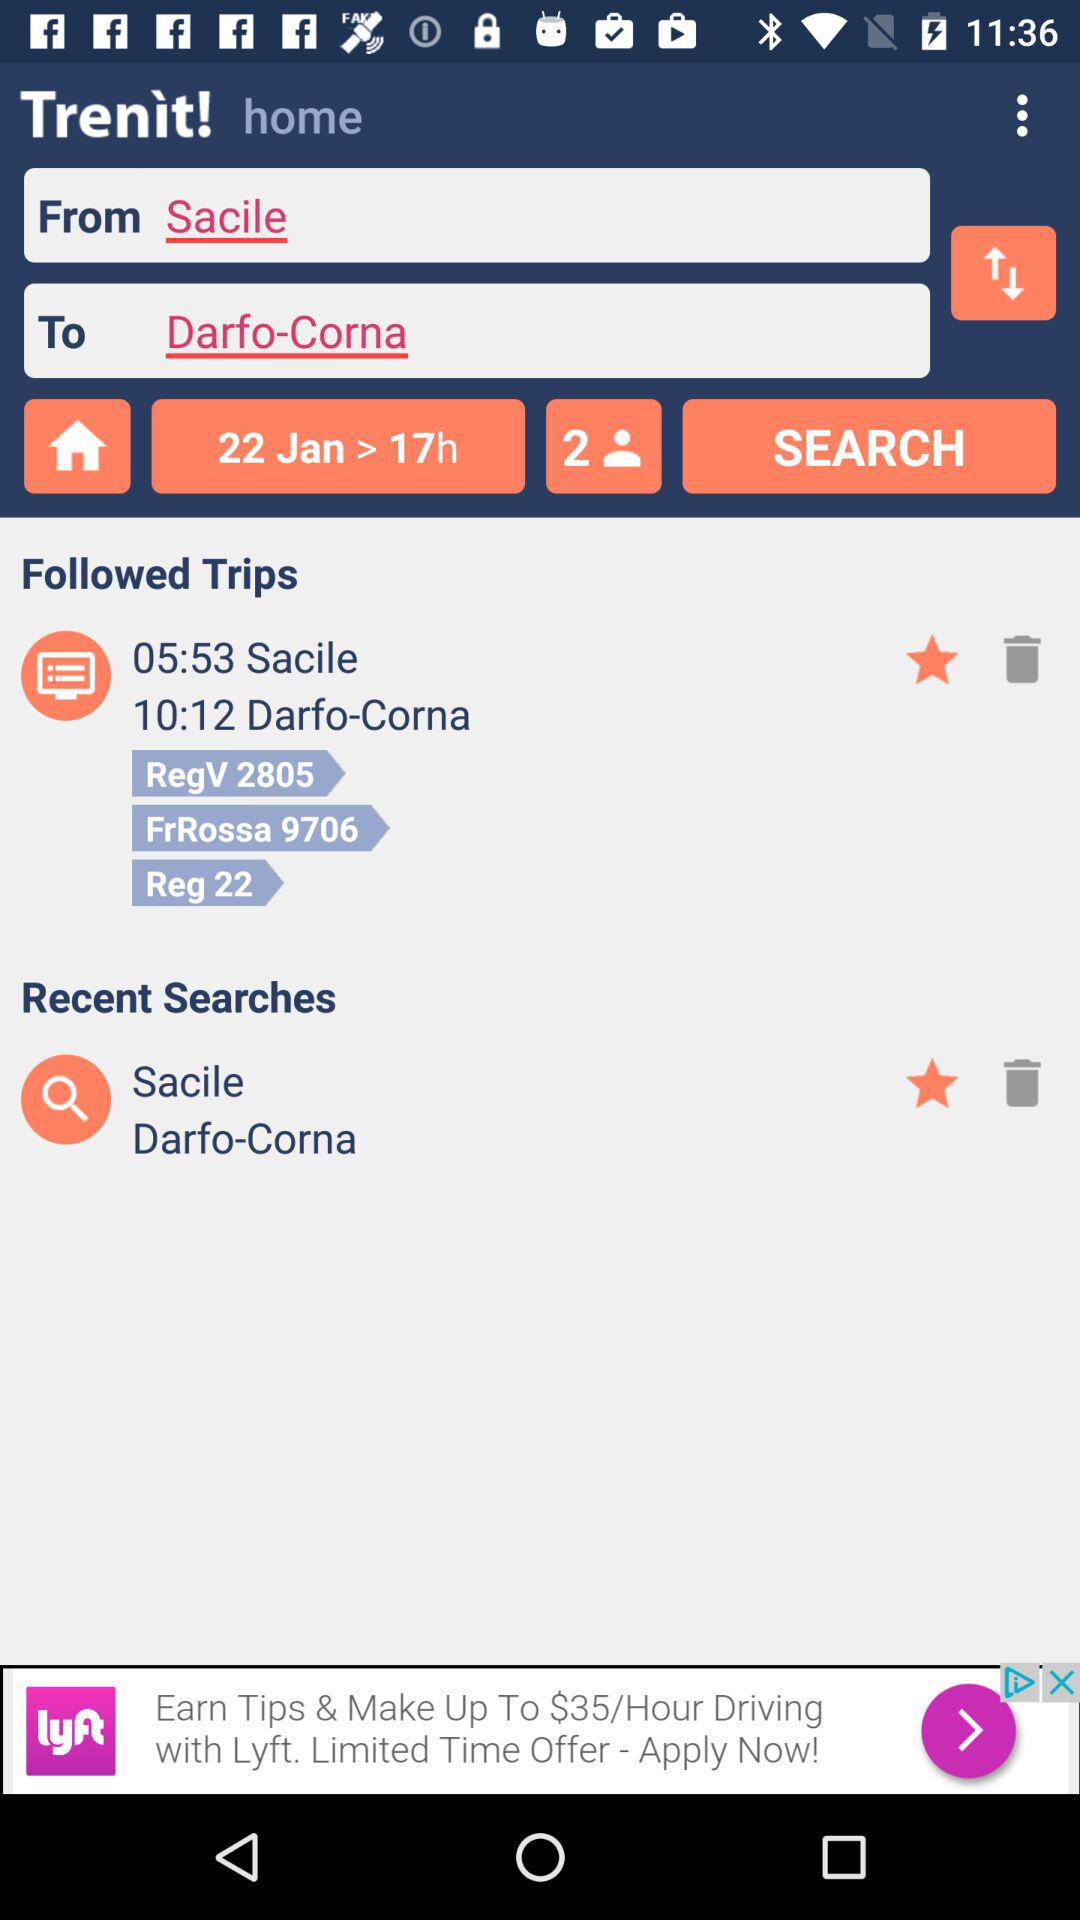What is the name of the application? The name of the application is "Trenit!". 